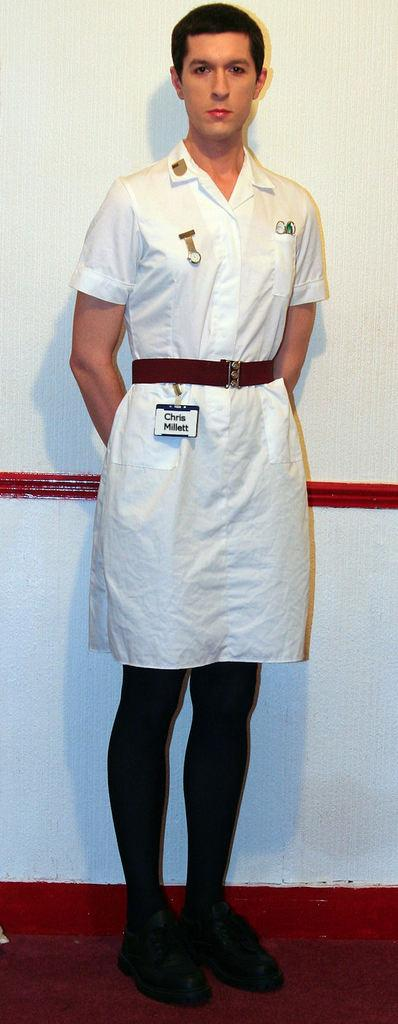Provide a one-sentence caption for the provided image. A person in a white uniform and a nametag that says Chris Millett stands for a picture. 